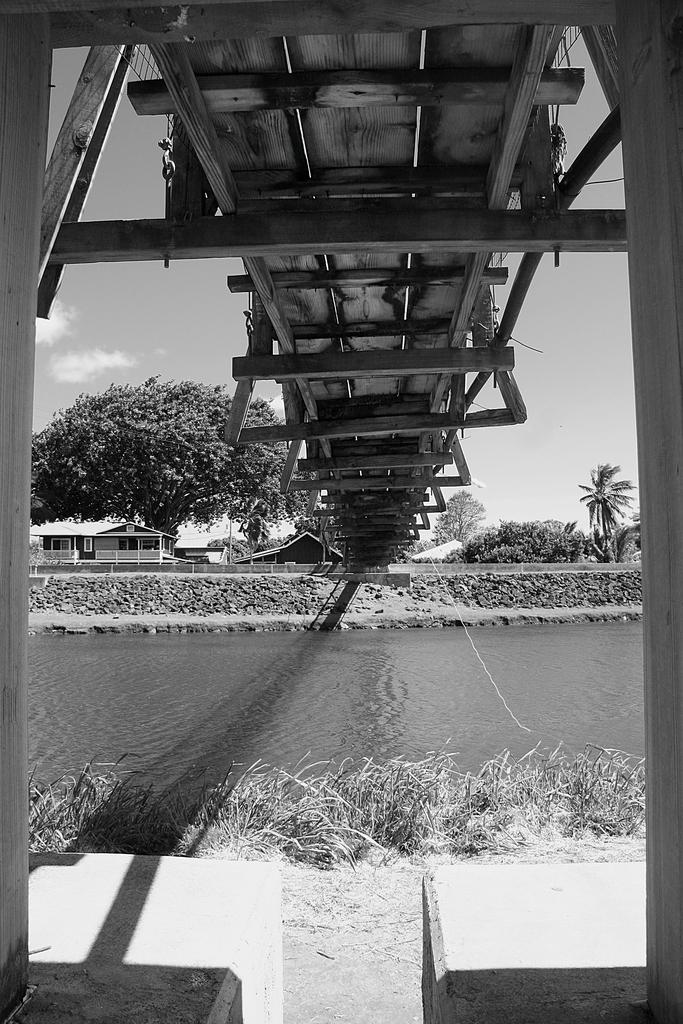What structure can be seen in the image? There is a bridge in the image. What natural element is visible in the image? There is water visible in the image. What type of vegetation is present in the image? There is grass in the image. What can be seen in the background of the image? There are trees, a house, and the sky visible in the background of the image. How does the hammer help to increase the height of the bridge in the image? There is no hammer present in the image, and the height of the bridge does not change. 